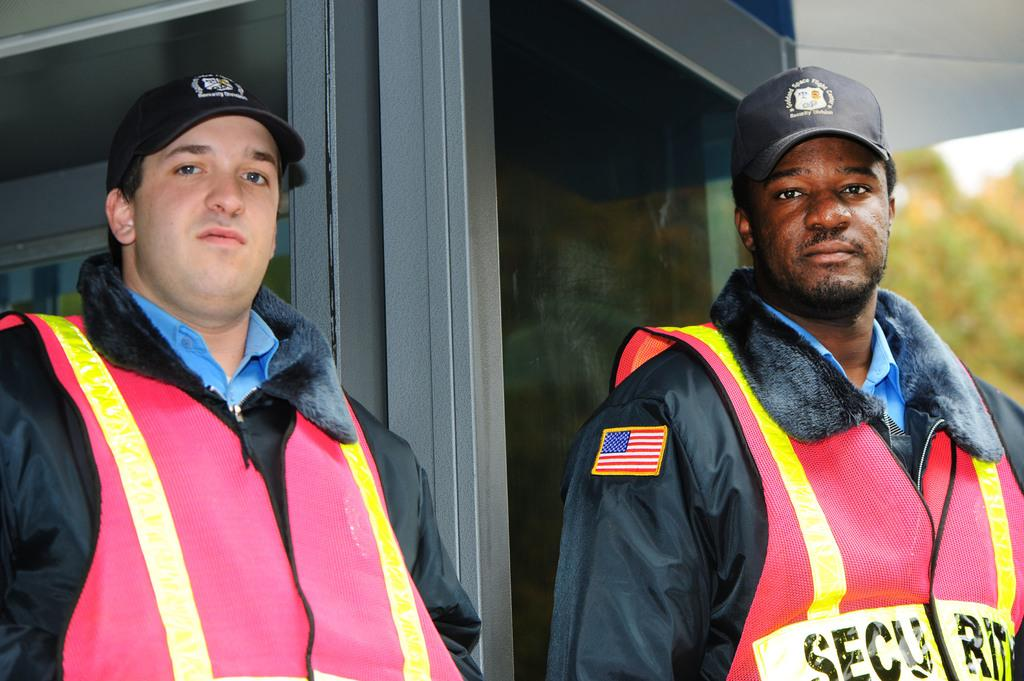How many people are in the image? There are two persons in the image. What are the people wearing on their upper bodies? Both persons are wearing blue shirts and jackets. What type of headgear are the people wearing? Both persons are wearing caps. Where are the two persons standing in the image? They are standing near a wall. What can be seen in the background of the image? The background of the image is slightly blurred, and trees are visible. Can you see a rifle in the hands of either person in the image? No, there is no rifle present in the image. What type of frog can be seen sitting on the wall near the two persons? There is no frog present in the image. 